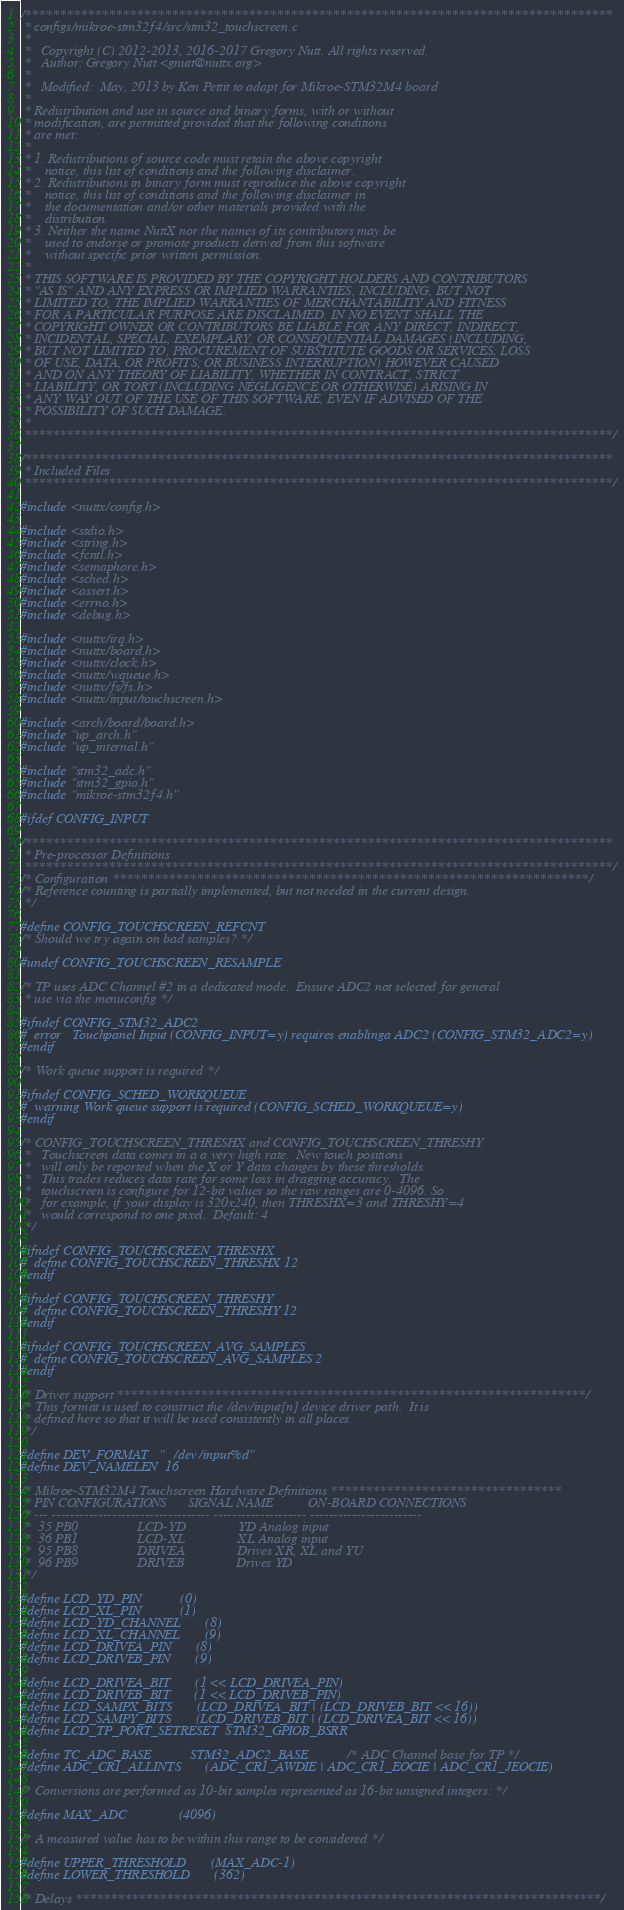<code> <loc_0><loc_0><loc_500><loc_500><_C_>/************************************************************************************
 * configs/mikroe-stm32f4/src/stm32_touchscreen.c
 *
 *   Copyright (C) 2012-2013, 2016-2017 Gregory Nutt. All rights reserved.
 *   Author: Gregory Nutt <gnutt@nuttx.org>
 *
 *   Modified:  May, 2013 by Ken Pettit to adapt for Mikroe-STM32M4 board
 *
 * Redistribution and use in source and binary forms, with or without
 * modification, are permitted provided that the following conditions
 * are met:
 *
 * 1. Redistributions of source code must retain the above copyright
 *    notice, this list of conditions and the following disclaimer.
 * 2. Redistributions in binary form must reproduce the above copyright
 *    notice, this list of conditions and the following disclaimer in
 *    the documentation and/or other materials provided with the
 *    distribution.
 * 3. Neither the name NuttX nor the names of its contributors may be
 *    used to endorse or promote products derived from this software
 *    without specific prior written permission.
 *
 * THIS SOFTWARE IS PROVIDED BY THE COPYRIGHT HOLDERS AND CONTRIBUTORS
 * "AS IS" AND ANY EXPRESS OR IMPLIED WARRANTIES, INCLUDING, BUT NOT
 * LIMITED TO, THE IMPLIED WARRANTIES OF MERCHANTABILITY AND FITNESS
 * FOR A PARTICULAR PURPOSE ARE DISCLAIMED. IN NO EVENT SHALL THE
 * COPYRIGHT OWNER OR CONTRIBUTORS BE LIABLE FOR ANY DIRECT, INDIRECT,
 * INCIDENTAL, SPECIAL, EXEMPLARY, OR CONSEQUENTIAL DAMAGES (INCLUDING,
 * BUT NOT LIMITED TO, PROCUREMENT OF SUBSTITUTE GOODS OR SERVICES; LOSS
 * OF USE, DATA, OR PROFITS; OR BUSINESS INTERRUPTION) HOWEVER CAUSED
 * AND ON ANY THEORY OF LIABILITY, WHETHER IN CONTRACT, STRICT
 * LIABILITY, OR TORT (INCLUDING NEGLIGENCE OR OTHERWISE) ARISING IN
 * ANY WAY OUT OF THE USE OF THIS SOFTWARE, EVEN IF ADVISED OF THE
 * POSSIBILITY OF SUCH DAMAGE.
 *
 ************************************************************************************/

/************************************************************************************
 * Included Files
 ************************************************************************************/

#include <nuttx/config.h>

#include <stdio.h>
#include <string.h>
#include <fcntl.h>
#include <semaphore.h>
#include <sched.h>
#include <assert.h>
#include <errno.h>
#include <debug.h>

#include <nuttx/irq.h>
#include <nuttx/board.h>
#include <nuttx/clock.h>
#include <nuttx/wqueue.h>
#include <nuttx/fs/fs.h>
#include <nuttx/input/touchscreen.h>

#include <arch/board/board.h>
#include "up_arch.h"
#include "up_internal.h"

#include "stm32_adc.h"
#include "stm32_gpio.h"
#include "mikroe-stm32f4.h"

#ifdef CONFIG_INPUT

/************************************************************************************
 * Pre-processor Definitions
 ************************************************************************************/
/* Configuration ********************************************************************/
/* Reference counting is partially implemented, but not needed in the current design.
 */

#define CONFIG_TOUCHSCREEN_REFCNT
/* Should we try again on bad samples? */

#undef CONFIG_TOUCHSCREEN_RESAMPLE

/* TP uses ADC Channel #2 in a dedicated mode.  Ensure ADC2 not selected for general
 * use via the menuconfig */

#ifndef CONFIG_STM32_ADC2
#  error   Touchpanel Input (CONFIG_INPUT=y) requires enablinga ADC2 (CONFIG_STM32_ADC2=y)
#endif

/* Work queue support is required */

#ifndef CONFIG_SCHED_WORKQUEUE
#  warning Work queue support is required (CONFIG_SCHED_WORKQUEUE=y)
#endif

/* CONFIG_TOUCHSCREEN_THRESHX and CONFIG_TOUCHSCREEN_THRESHY
 *   Touchscreen data comes in a a very high rate.  New touch positions
 *   will only be reported when the X or Y data changes by these thresholds.
 *   This trades reduces data rate for some loss in dragging accuracy.  The
 *   touchscreen is configure for 12-bit values so the raw ranges are 0-4096. So
 *   for example, if your display is 320x240, then THRESHX=3 and THRESHY=4
 *   would correspond to one pixel.  Default: 4
 */

#ifndef CONFIG_TOUCHSCREEN_THRESHX
#  define CONFIG_TOUCHSCREEN_THRESHX 12
#endif

#ifndef CONFIG_TOUCHSCREEN_THRESHY
#  define CONFIG_TOUCHSCREEN_THRESHY 12
#endif

#ifndef CONFIG_TOUCHSCREEN_AVG_SAMPLES
#  define CONFIG_TOUCHSCREEN_AVG_SAMPLES 2
#endif

/* Driver support *******************************************************************/
/* This format is used to construct the /dev/input[n] device driver path.  It is
 * defined here so that it will be used consistently in all places.
 */

#define DEV_FORMAT   "/dev/input%d"
#define DEV_NAMELEN  16

/* Mikroe-STM32M4 Touchscreen Hardware Definitions *********************************
 * PIN CONFIGURATIONS      SIGNAL NAME          ON-BOARD CONNECTIONS
 * --- ---------------------------------- -------------------- ------------------------
 *  35 PB0                 LCD-YD               YD Analog input
 *  36 PB1                 LCD-XL               XL Analog input
 *  95 PB8                 DRIVEA               Drives XR, XL and YU
 *  96 PB9                 DRIVEB               Drives YD
 */

#define LCD_YD_PIN           (0)
#define LCD_XL_PIN           (1)
#define LCD_YD_CHANNEL       (8)
#define LCD_XL_CHANNEL       (9)
#define LCD_DRIVEA_PIN       (8)
#define LCD_DRIVEB_PIN       (9)

#define LCD_DRIVEA_BIT       (1 << LCD_DRIVEA_PIN)
#define LCD_DRIVEB_BIT       (1 << LCD_DRIVEB_PIN)
#define LCD_SAMPX_BITS       (LCD_DRIVEA_BIT | (LCD_DRIVEB_BIT << 16))
#define LCD_SAMPY_BITS       (LCD_DRIVEB_BIT | (LCD_DRIVEA_BIT << 16))
#define LCD_TP_PORT_SETRESET  STM32_GPIOB_BSRR

#define TC_ADC_BASE           STM32_ADC2_BASE      /* ADC Channel base for TP */
#define ADC_CR1_ALLINTS       (ADC_CR1_AWDIE | ADC_CR1_EOCIE | ADC_CR1_JEOCIE)

/* Conversions are performed as 10-bit samples represented as 16-bit unsigned integers: */

#define MAX_ADC               (4096)

/* A measured value has to be within this range to be considered */

#define UPPER_THRESHOLD       (MAX_ADC-1)
#define LOWER_THRESHOLD       (362)

/* Delays ***************************************************************************/</code> 